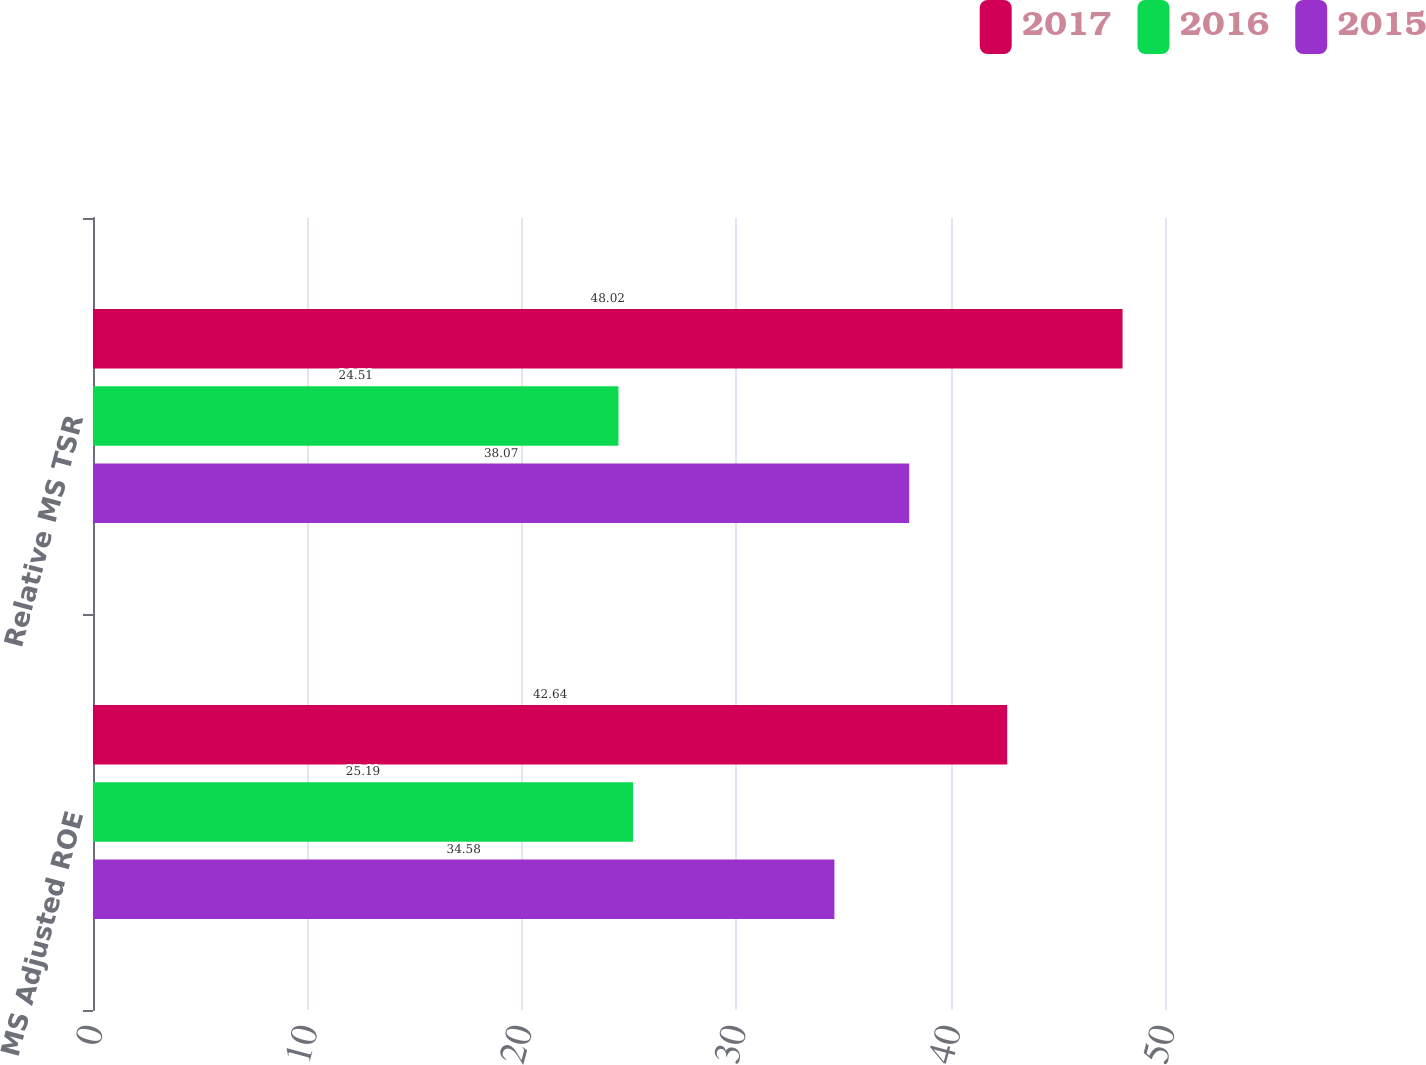<chart> <loc_0><loc_0><loc_500><loc_500><stacked_bar_chart><ecel><fcel>MS Adjusted ROE<fcel>Relative MS TSR<nl><fcel>2017<fcel>42.64<fcel>48.02<nl><fcel>2016<fcel>25.19<fcel>24.51<nl><fcel>2015<fcel>34.58<fcel>38.07<nl></chart> 